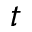Convert formula to latex. <formula><loc_0><loc_0><loc_500><loc_500>t</formula> 